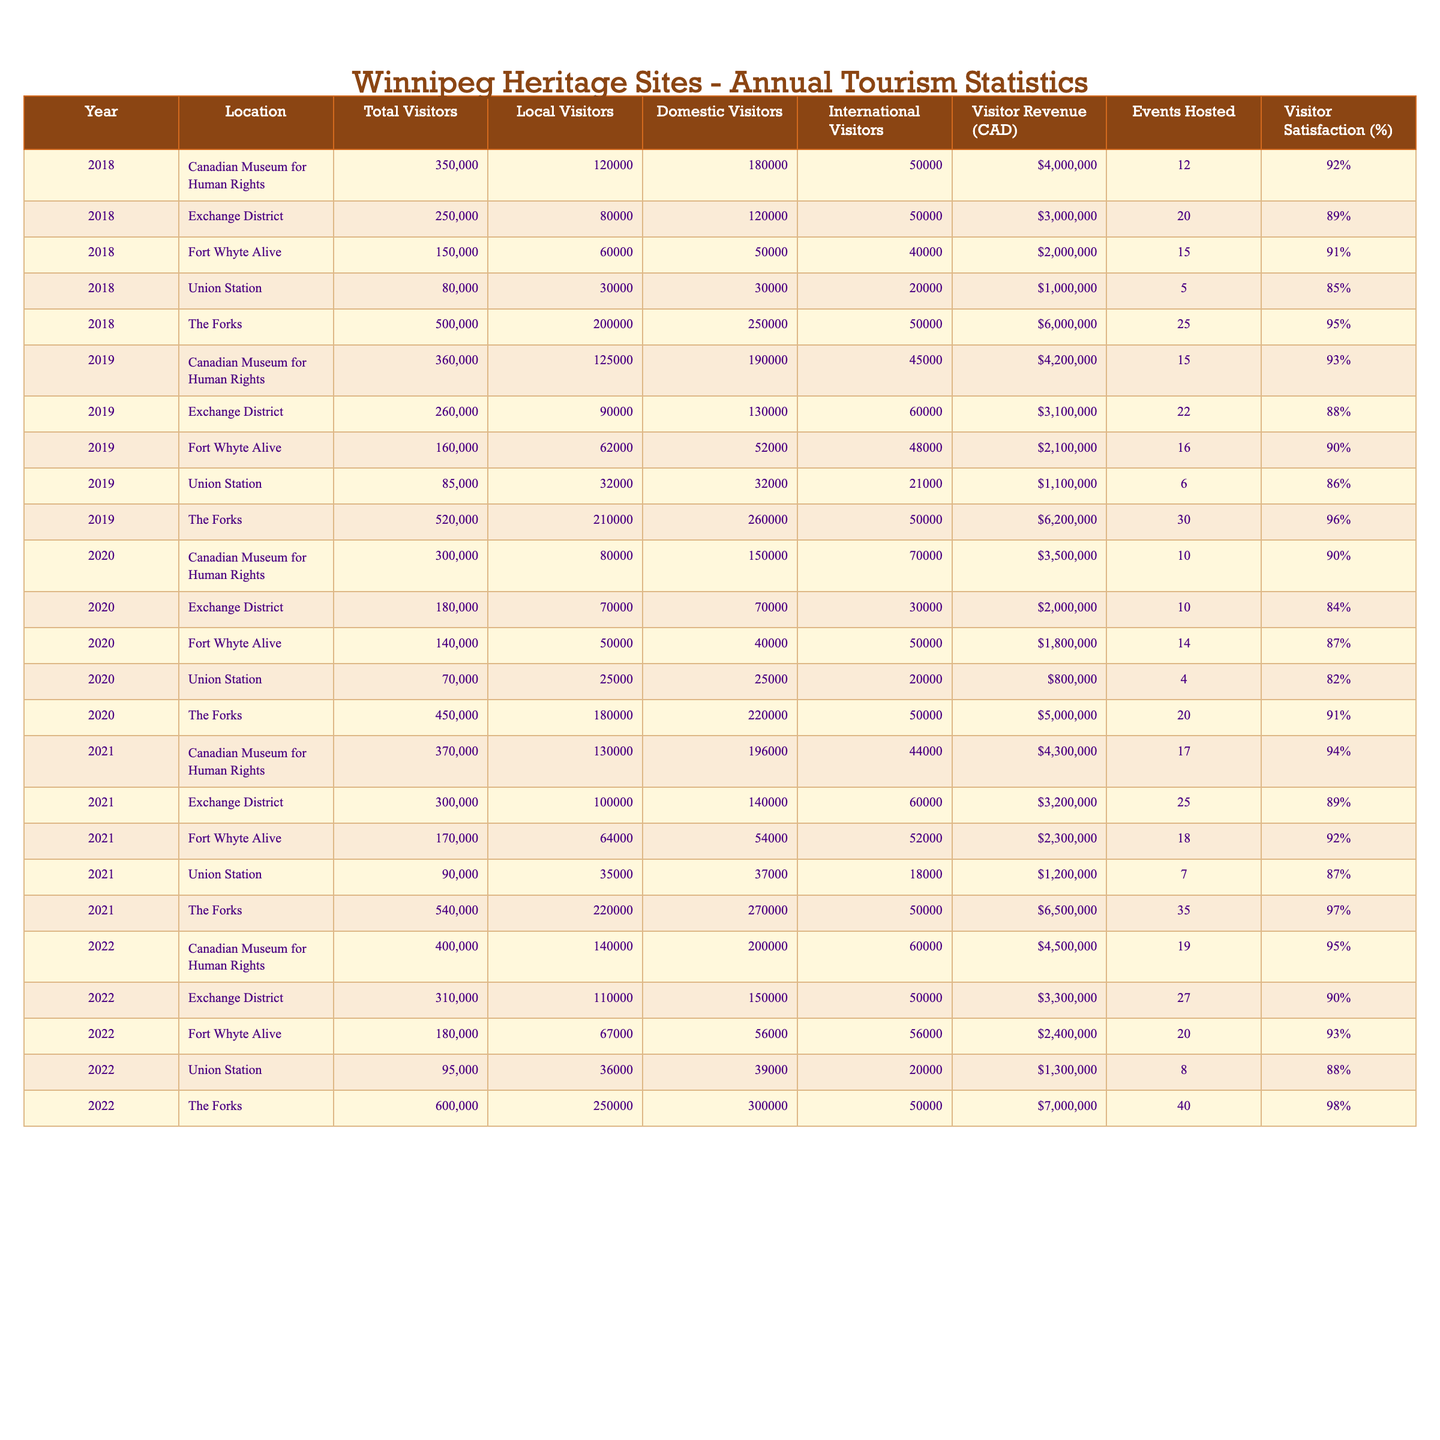What's the total number of visitors to The Forks in 2022? In the table under the year 2022 for The Forks, the Total Visitors value is listed as 600,000.
Answer: 600,000 What was the visitor satisfaction percentage for Union Station in 2019? The satisfaction percentage for Union Station in 2019 is located in the corresponding row and is recorded as 86%.
Answer: 86% In which year did the Canadian Museum for Human Rights receive the highest number of visitors? To determine the highest number of visitors, we compare the Total Visitors values for each year. The maximum value is 400,000 in 2022.
Answer: 2022 Which heritage site had the highest visitor revenue in 2021? Reviewing the Visitor Revenue for 2021, The Forks had the highest amount listed at 6,500,000 CAD.
Answer: The Forks What is the total number of visitors to Fort Whyte Alive across all years in the table? Summing the Total Visitors for Fort Whyte Alive for the years provided (150,000 + 160,000 + 140,000 + 170,000 + 180,000) equals 900,000.
Answer: 900,000 Did the number of local visitors to the Exchange District exceed 100,000 in any year? Analyzing the Local Visitors column for Exchange District, the values show that it exceeds 100,000 only in 2021 when it reached 100,000 exactly.
Answer: Yes What was the average Visitor Satisfaction percentage for all sites in 2018? To calculate the average for 2018, we sum all visitor satisfaction values for that year (92 + 89 + 91 + 85 + 95 = 452) and divide by 5, yielding 90.4%.
Answer: 90.4% Is the number of domestic visitors to the Canadian Museum for Human Rights consistently increasing each year? Looking at the Domestic Visitors values, they are 180,000 in 2018, 190,000 in 2019, 150,000 in 2020, 196,000 in 2021, and 200,000 in 2022, showing an increase except for a drop in 2020.
Answer: No What is the difference in Visitor Revenue between The Forks in 2022 and in 2019? The Visitor Revenue for The Forks is 7,000,000 CAD in 2022 and 6,200,000 CAD in 2019. The difference is 7,000,000 - 6,200,000 = 800,000 CAD.
Answer: 800,000 CAD Which site hosted the most events in 2022? Checking the Events Hosted for each site in 2022, The Forks hosted the most events at 40.
Answer: The Forks 